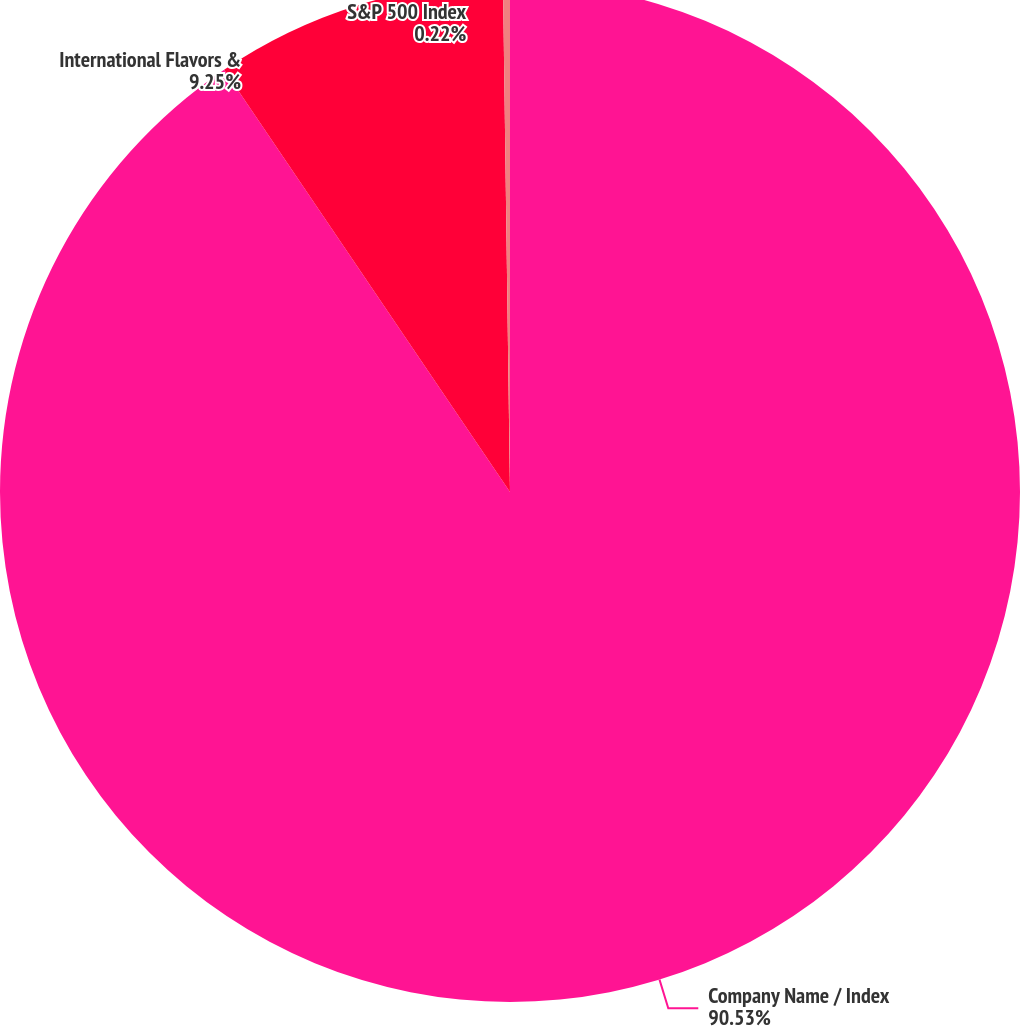<chart> <loc_0><loc_0><loc_500><loc_500><pie_chart><fcel>Company Name / Index<fcel>International Flavors &<fcel>S&P 500 Index<nl><fcel>90.53%<fcel>9.25%<fcel>0.22%<nl></chart> 